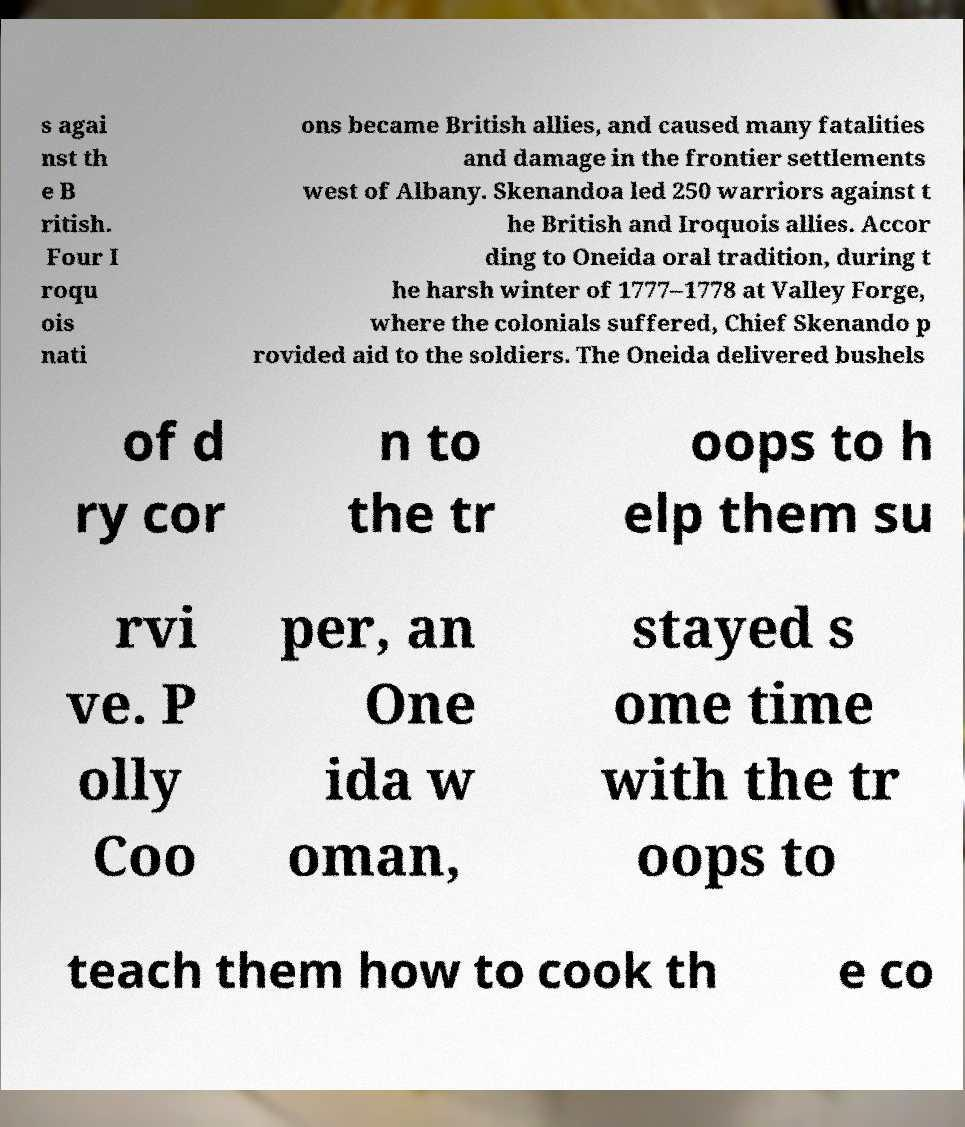Can you read and provide the text displayed in the image?This photo seems to have some interesting text. Can you extract and type it out for me? s agai nst th e B ritish. Four I roqu ois nati ons became British allies, and caused many fatalities and damage in the frontier settlements west of Albany. Skenandoa led 250 warriors against t he British and Iroquois allies. Accor ding to Oneida oral tradition, during t he harsh winter of 1777–1778 at Valley Forge, where the colonials suffered, Chief Skenando p rovided aid to the soldiers. The Oneida delivered bushels of d ry cor n to the tr oops to h elp them su rvi ve. P olly Coo per, an One ida w oman, stayed s ome time with the tr oops to teach them how to cook th e co 